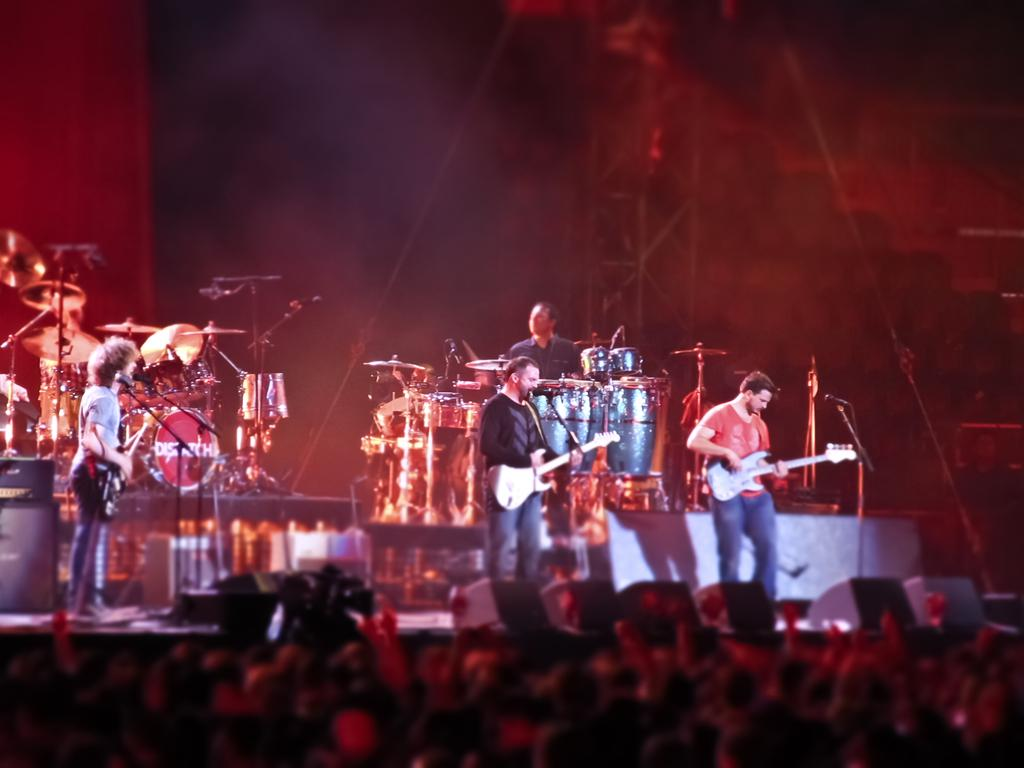What are the people in the image doing? The people in the image are standing and playing guitars, and there are men seated and playing drums. Where are the musicians located in the image? The musicians are on a dais in the image. What equipment is visible in the image that might be used for amplifying sound? Microphones are visible in the image. Who is present in the image besides the musicians? There is an audience in the image. What device is present in the image that might be used for recording the performance? A camera is present in the image. Where is the playground located in the image? There is no playground present in the image. What type of industry is depicted in the image? The image does not depict any industry; it features musicians performing on a dais. 